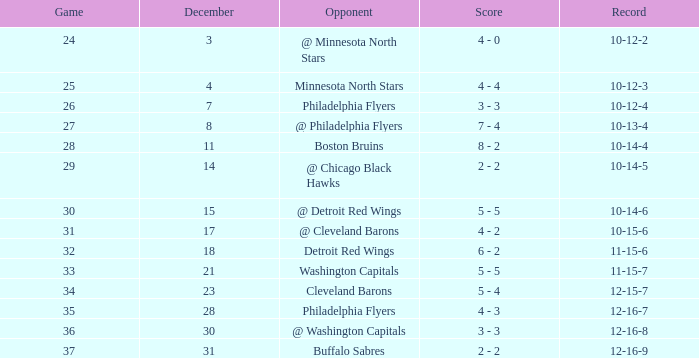What is the minimum december, when score is "4 - 4"? 4.0. 